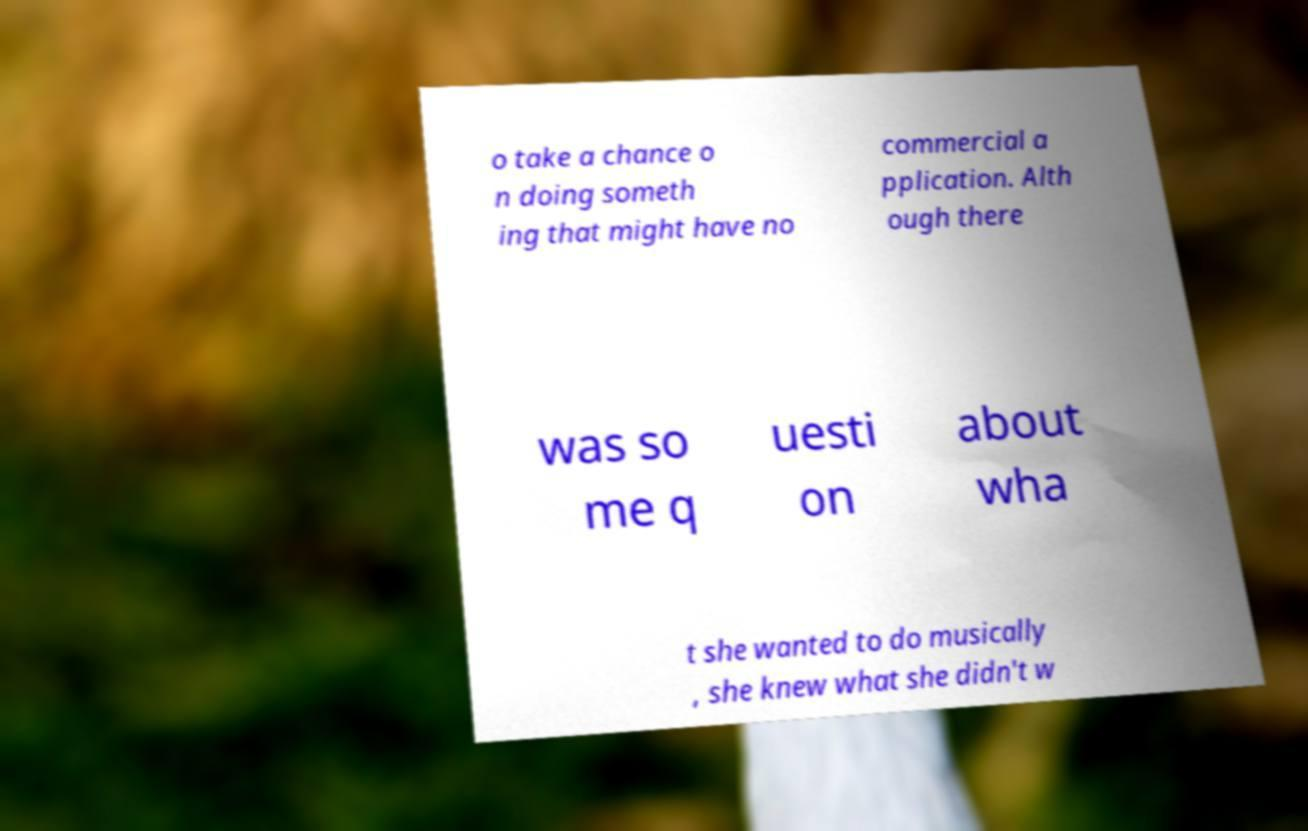For documentation purposes, I need the text within this image transcribed. Could you provide that? o take a chance o n doing someth ing that might have no commercial a pplication. Alth ough there was so me q uesti on about wha t she wanted to do musically , she knew what she didn't w 